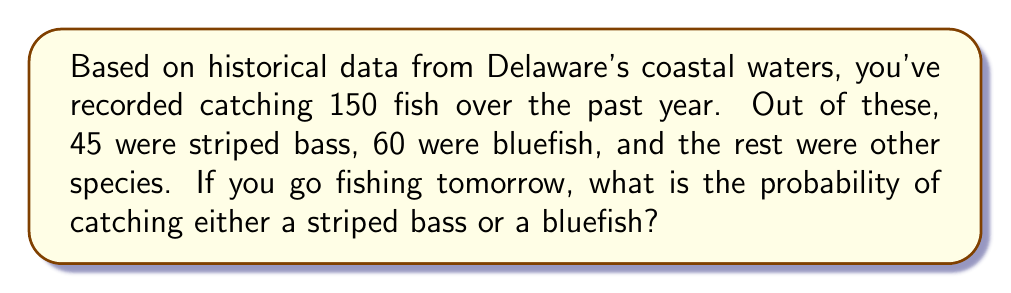Give your solution to this math problem. Let's approach this step-by-step:

1. First, we need to identify the total number of fish caught and the number of striped bass and bluefish:
   - Total fish caught: 150
   - Striped bass: 45
   - Bluefish: 60

2. To find the probability of catching either a striped bass or a bluefish, we need to add their individual probabilities:

   $P(\text{striped bass or bluefish}) = P(\text{striped bass}) + P(\text{bluefish})$

3. Calculate the probability of catching a striped bass:
   $P(\text{striped bass}) = \frac{\text{number of striped bass}}{\text{total number of fish}} = \frac{45}{150} = 0.3$

4. Calculate the probability of catching a bluefish:
   $P(\text{bluefish}) = \frac{\text{number of bluefish}}{\text{total number of fish}} = \frac{60}{150} = 0.4$

5. Now, add these probabilities:
   $P(\text{striped bass or bluefish}) = 0.3 + 0.4 = 0.7$

6. Convert the decimal to a percentage:
   $0.7 \times 100\% = 70\%$

Therefore, based on the historical data, the probability of catching either a striped bass or a bluefish on your next fishing trip is 70%.
Answer: 70% 